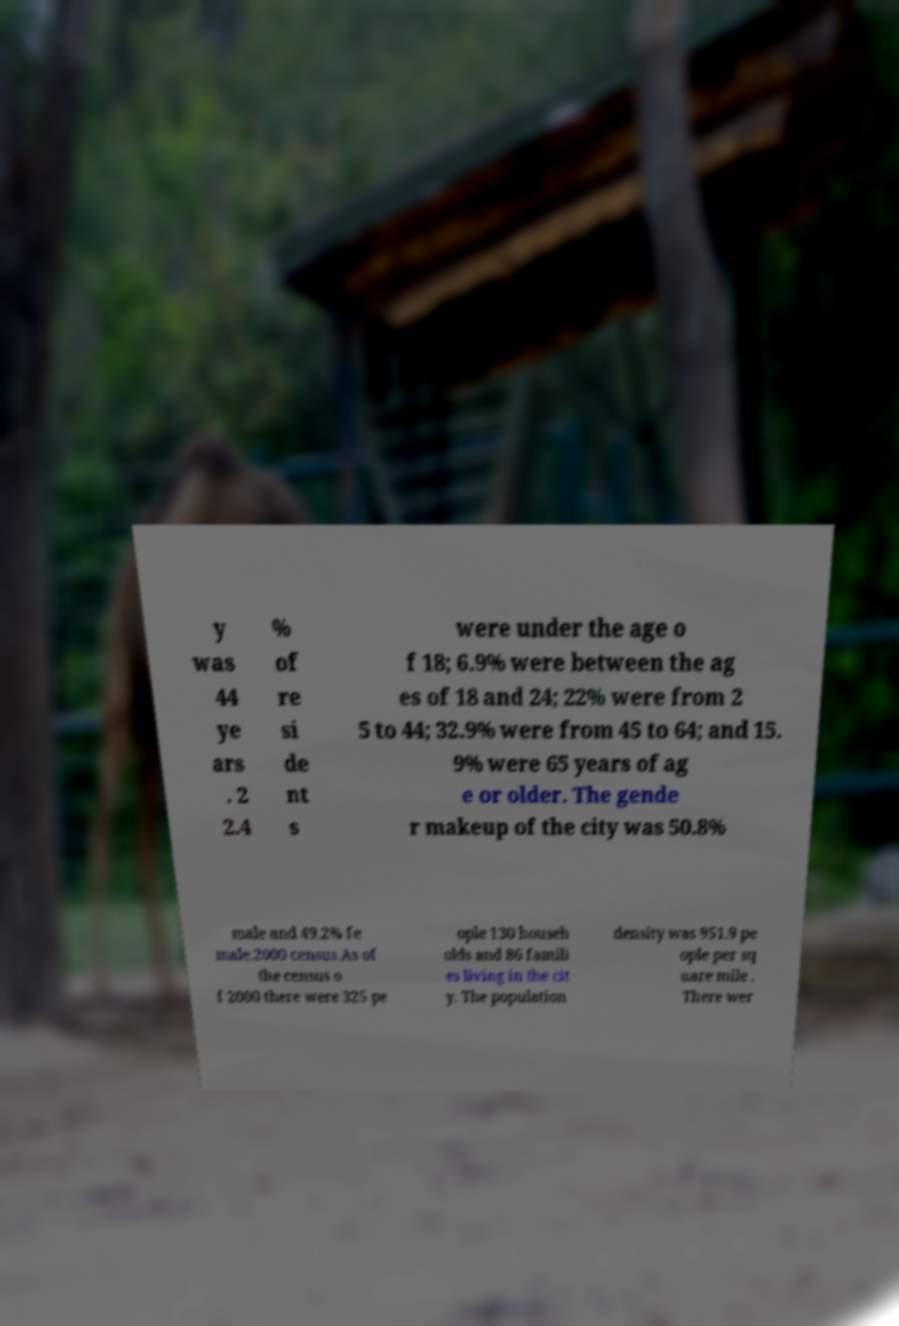Can you accurately transcribe the text from the provided image for me? y was 44 ye ars . 2 2.4 % of re si de nt s were under the age o f 18; 6.9% were between the ag es of 18 and 24; 22% were from 2 5 to 44; 32.9% were from 45 to 64; and 15. 9% were 65 years of ag e or older. The gende r makeup of the city was 50.8% male and 49.2% fe male.2000 census.As of the census o f 2000 there were 325 pe ople 130 househ olds and 86 famili es living in the cit y. The population density was 951.9 pe ople per sq uare mile . There wer 